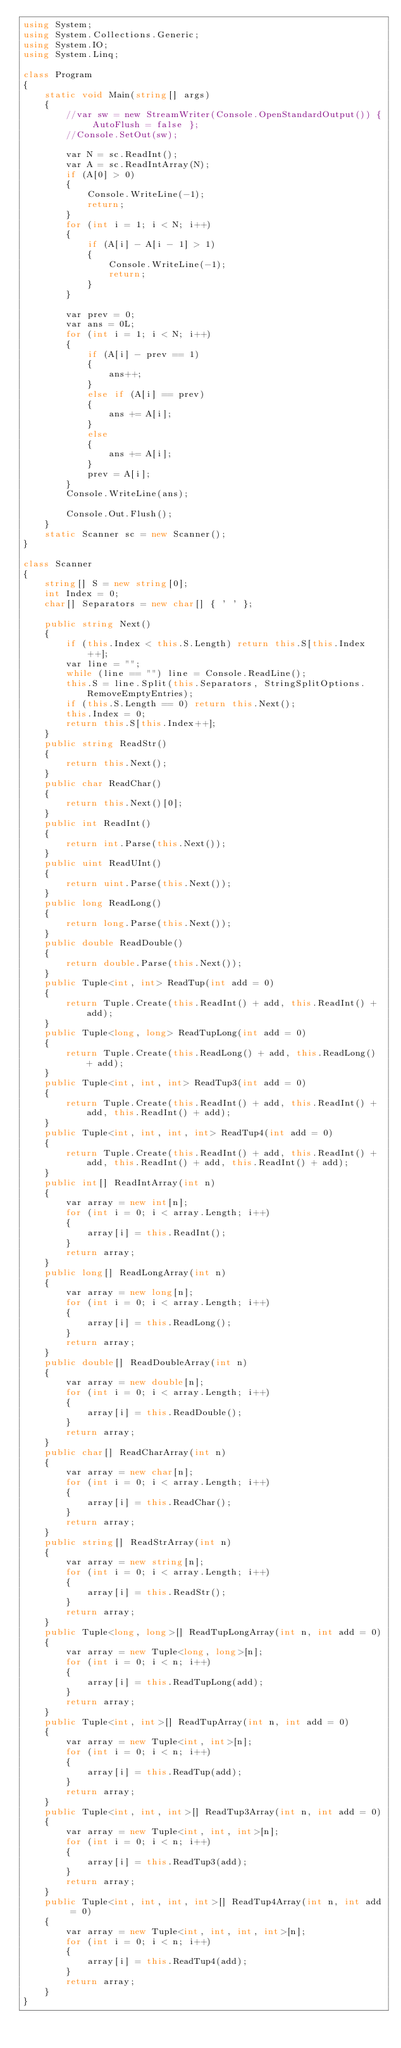Convert code to text. <code><loc_0><loc_0><loc_500><loc_500><_C#_>using System;
using System.Collections.Generic;
using System.IO;
using System.Linq;

class Program
{
    static void Main(string[] args)
    {
        //var sw = new StreamWriter(Console.OpenStandardOutput()) { AutoFlush = false };
        //Console.SetOut(sw);

        var N = sc.ReadInt();
        var A = sc.ReadIntArray(N);
        if (A[0] > 0)
        {
            Console.WriteLine(-1);
            return;
        }
        for (int i = 1; i < N; i++)
        {
            if (A[i] - A[i - 1] > 1)
            {
                Console.WriteLine(-1);
                return;
            }
        }

        var prev = 0;
        var ans = 0L;
        for (int i = 1; i < N; i++)
        {
            if (A[i] - prev == 1)
            {
                ans++;
            }
            else if (A[i] == prev)
            {
                ans += A[i];
            }
            else
            {
                ans += A[i];
            }
            prev = A[i];
        }
        Console.WriteLine(ans);

        Console.Out.Flush();
    }
    static Scanner sc = new Scanner();
}

class Scanner
{
    string[] S = new string[0];
    int Index = 0;
    char[] Separators = new char[] { ' ' };

    public string Next()
    {
        if (this.Index < this.S.Length) return this.S[this.Index++];
        var line = "";
        while (line == "") line = Console.ReadLine();
        this.S = line.Split(this.Separators, StringSplitOptions.RemoveEmptyEntries);
        if (this.S.Length == 0) return this.Next();
        this.Index = 0;
        return this.S[this.Index++];
    }
    public string ReadStr()
    {
        return this.Next();
    }
    public char ReadChar()
    {
        return this.Next()[0];
    }
    public int ReadInt()
    {
        return int.Parse(this.Next());
    }
    public uint ReadUInt()
    {
        return uint.Parse(this.Next());
    }
    public long ReadLong()
    {
        return long.Parse(this.Next());
    }
    public double ReadDouble()
    {
        return double.Parse(this.Next());
    }
    public Tuple<int, int> ReadTup(int add = 0)
    {
        return Tuple.Create(this.ReadInt() + add, this.ReadInt() + add);
    }
    public Tuple<long, long> ReadTupLong(int add = 0)
    {
        return Tuple.Create(this.ReadLong() + add, this.ReadLong() + add);
    }
    public Tuple<int, int, int> ReadTup3(int add = 0)
    {
        return Tuple.Create(this.ReadInt() + add, this.ReadInt() + add, this.ReadInt() + add);
    }
    public Tuple<int, int, int, int> ReadTup4(int add = 0)
    {
        return Tuple.Create(this.ReadInt() + add, this.ReadInt() + add, this.ReadInt() + add, this.ReadInt() + add);
    }
    public int[] ReadIntArray(int n)
    {
        var array = new int[n];
        for (int i = 0; i < array.Length; i++)
        {
            array[i] = this.ReadInt();
        }
        return array;
    }
    public long[] ReadLongArray(int n)
    {
        var array = new long[n];
        for (int i = 0; i < array.Length; i++)
        {
            array[i] = this.ReadLong();
        }
        return array;
    }
    public double[] ReadDoubleArray(int n)
    {
        var array = new double[n];
        for (int i = 0; i < array.Length; i++)
        {
            array[i] = this.ReadDouble();
        }
        return array;
    }
    public char[] ReadCharArray(int n)
    {
        var array = new char[n];
        for (int i = 0; i < array.Length; i++)
        {
            array[i] = this.ReadChar();
        }
        return array;
    }
    public string[] ReadStrArray(int n)
    {
        var array = new string[n];
        for (int i = 0; i < array.Length; i++)
        {
            array[i] = this.ReadStr();
        }
        return array;
    }
    public Tuple<long, long>[] ReadTupLongArray(int n, int add = 0)
    {
        var array = new Tuple<long, long>[n];
        for (int i = 0; i < n; i++)
        {
            array[i] = this.ReadTupLong(add);
        }
        return array;
    }
    public Tuple<int, int>[] ReadTupArray(int n, int add = 0)
    {
        var array = new Tuple<int, int>[n];
        for (int i = 0; i < n; i++)
        {
            array[i] = this.ReadTup(add);
        }
        return array;
    }
    public Tuple<int, int, int>[] ReadTup3Array(int n, int add = 0)
    {
        var array = new Tuple<int, int, int>[n];
        for (int i = 0; i < n; i++)
        {
            array[i] = this.ReadTup3(add);
        }
        return array;
    }
    public Tuple<int, int, int, int>[] ReadTup4Array(int n, int add = 0)
    {
        var array = new Tuple<int, int, int, int>[n];
        for (int i = 0; i < n; i++)
        {
            array[i] = this.ReadTup4(add);
        }
        return array;
    }
}
</code> 